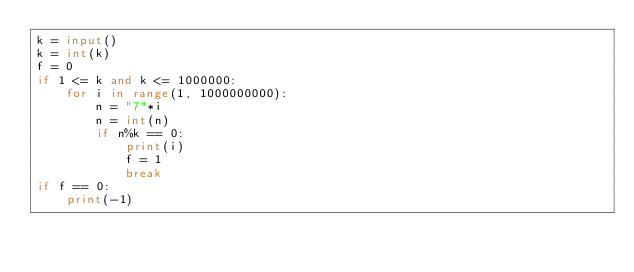<code> <loc_0><loc_0><loc_500><loc_500><_Python_>k = input()
k = int(k)
f = 0
if 1 <= k and k <= 1000000:
    for i in range(1, 1000000000):
        n = "7"*i
        n = int(n)
        if n%k == 0:
            print(i)
            f = 1
            break
if f == 0:
    print(-1)</code> 